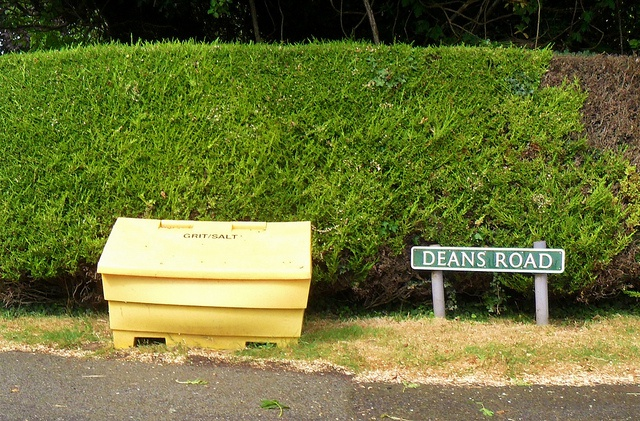Describe the objects in this image and their specific colors. I can see various objects in this image with different colors. 